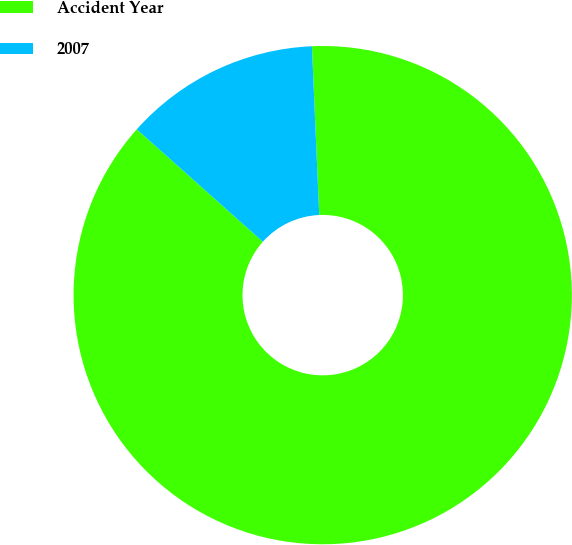Convert chart to OTSL. <chart><loc_0><loc_0><loc_500><loc_500><pie_chart><fcel>Accident Year<fcel>2007<nl><fcel>87.28%<fcel>12.72%<nl></chart> 